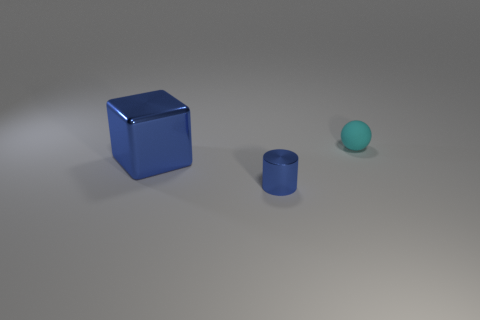What shape is the blue metal thing that is on the right side of the blue thing on the left side of the small object in front of the cyan ball?
Provide a short and direct response. Cylinder. Is the shape of the large blue metal thing the same as the small matte thing?
Your answer should be compact. No. How many other things are the same shape as the tiny cyan object?
Provide a succinct answer. 0. What is the color of the other metal object that is the same size as the cyan thing?
Give a very brief answer. Blue. Is the number of big metal blocks in front of the cube the same as the number of rubber blocks?
Your answer should be very brief. Yes. What shape is the thing that is both to the left of the small rubber ball and behind the metal cylinder?
Keep it short and to the point. Cube. Do the blue metallic cylinder and the cyan thing have the same size?
Your response must be concise. Yes. Is there a small cylinder made of the same material as the ball?
Provide a succinct answer. No. There is a metallic object that is the same color as the cylinder; what size is it?
Your response must be concise. Large. What number of tiny objects are both behind the metal block and in front of the cyan matte ball?
Give a very brief answer. 0. 